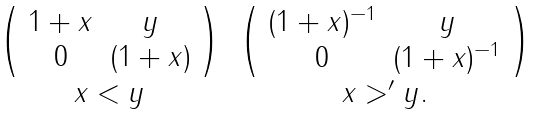<formula> <loc_0><loc_0><loc_500><loc_500>\begin{array} { c c } \left ( \begin{array} { c c } 1 + x & y \\ 0 & ( 1 + x ) \end{array} \right ) & \left ( \begin{array} { c c } ( 1 + x ) ^ { - 1 } & y \\ 0 & ( 1 + x ) ^ { - 1 } \end{array} \right ) \\ x < y & x > ^ { \prime } y . \end{array}</formula> 